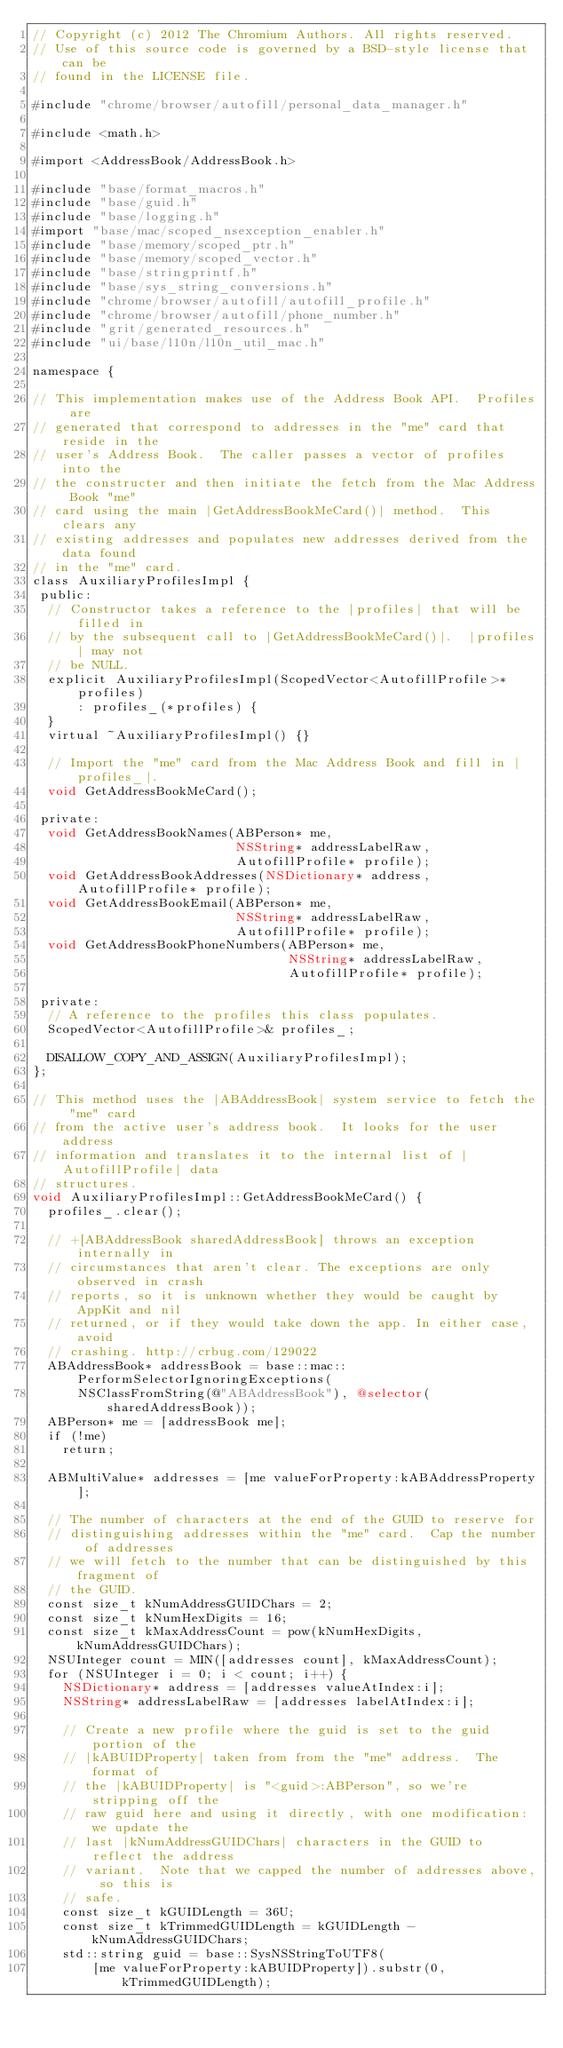<code> <loc_0><loc_0><loc_500><loc_500><_ObjectiveC_>// Copyright (c) 2012 The Chromium Authors. All rights reserved.
// Use of this source code is governed by a BSD-style license that can be
// found in the LICENSE file.

#include "chrome/browser/autofill/personal_data_manager.h"

#include <math.h>

#import <AddressBook/AddressBook.h>

#include "base/format_macros.h"
#include "base/guid.h"
#include "base/logging.h"
#import "base/mac/scoped_nsexception_enabler.h"
#include "base/memory/scoped_ptr.h"
#include "base/memory/scoped_vector.h"
#include "base/stringprintf.h"
#include "base/sys_string_conversions.h"
#include "chrome/browser/autofill/autofill_profile.h"
#include "chrome/browser/autofill/phone_number.h"
#include "grit/generated_resources.h"
#include "ui/base/l10n/l10n_util_mac.h"

namespace {

// This implementation makes use of the Address Book API.  Profiles are
// generated that correspond to addresses in the "me" card that reside in the
// user's Address Book.  The caller passes a vector of profiles into the
// the constructer and then initiate the fetch from the Mac Address Book "me"
// card using the main |GetAddressBookMeCard()| method.  This clears any
// existing addresses and populates new addresses derived from the data found
// in the "me" card.
class AuxiliaryProfilesImpl {
 public:
  // Constructor takes a reference to the |profiles| that will be filled in
  // by the subsequent call to |GetAddressBookMeCard()|.  |profiles| may not
  // be NULL.
  explicit AuxiliaryProfilesImpl(ScopedVector<AutofillProfile>* profiles)
      : profiles_(*profiles) {
  }
  virtual ~AuxiliaryProfilesImpl() {}

  // Import the "me" card from the Mac Address Book and fill in |profiles_|.
  void GetAddressBookMeCard();

 private:
  void GetAddressBookNames(ABPerson* me,
                           NSString* addressLabelRaw,
                           AutofillProfile* profile);
  void GetAddressBookAddresses(NSDictionary* address, AutofillProfile* profile);
  void GetAddressBookEmail(ABPerson* me,
                           NSString* addressLabelRaw,
                           AutofillProfile* profile);
  void GetAddressBookPhoneNumbers(ABPerson* me,
                                  NSString* addressLabelRaw,
                                  AutofillProfile* profile);

 private:
  // A reference to the profiles this class populates.
  ScopedVector<AutofillProfile>& profiles_;

  DISALLOW_COPY_AND_ASSIGN(AuxiliaryProfilesImpl);
};

// This method uses the |ABAddressBook| system service to fetch the "me" card
// from the active user's address book.  It looks for the user address
// information and translates it to the internal list of |AutofillProfile| data
// structures.
void AuxiliaryProfilesImpl::GetAddressBookMeCard() {
  profiles_.clear();

  // +[ABAddressBook sharedAddressBook] throws an exception internally in
  // circumstances that aren't clear. The exceptions are only observed in crash
  // reports, so it is unknown whether they would be caught by AppKit and nil
  // returned, or if they would take down the app. In either case, avoid
  // crashing. http://crbug.com/129022
  ABAddressBook* addressBook = base::mac::PerformSelectorIgnoringExceptions(
      NSClassFromString(@"ABAddressBook"), @selector(sharedAddressBook));
  ABPerson* me = [addressBook me];
  if (!me)
    return;

  ABMultiValue* addresses = [me valueForProperty:kABAddressProperty];

  // The number of characters at the end of the GUID to reserve for
  // distinguishing addresses within the "me" card.  Cap the number of addresses
  // we will fetch to the number that can be distinguished by this fragment of
  // the GUID.
  const size_t kNumAddressGUIDChars = 2;
  const size_t kNumHexDigits = 16;
  const size_t kMaxAddressCount = pow(kNumHexDigits, kNumAddressGUIDChars);
  NSUInteger count = MIN([addresses count], kMaxAddressCount);
  for (NSUInteger i = 0; i < count; i++) {
    NSDictionary* address = [addresses valueAtIndex:i];
    NSString* addressLabelRaw = [addresses labelAtIndex:i];

    // Create a new profile where the guid is set to the guid portion of the
    // |kABUIDProperty| taken from from the "me" address.  The format of
    // the |kABUIDProperty| is "<guid>:ABPerson", so we're stripping off the
    // raw guid here and using it directly, with one modification: we update the
    // last |kNumAddressGUIDChars| characters in the GUID to reflect the address
    // variant.  Note that we capped the number of addresses above, so this is
    // safe.
    const size_t kGUIDLength = 36U;
    const size_t kTrimmedGUIDLength = kGUIDLength - kNumAddressGUIDChars;
    std::string guid = base::SysNSStringToUTF8(
        [me valueForProperty:kABUIDProperty]).substr(0, kTrimmedGUIDLength);
</code> 